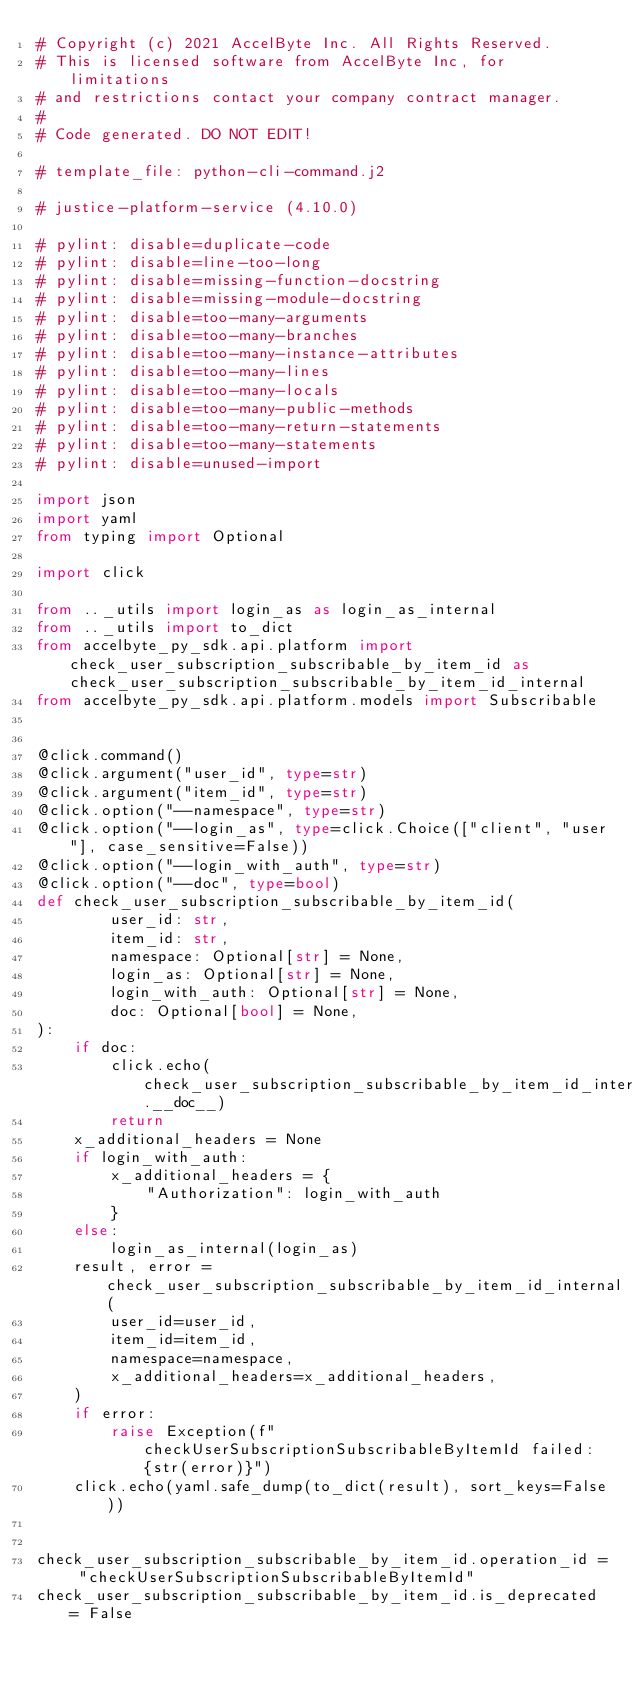Convert code to text. <code><loc_0><loc_0><loc_500><loc_500><_Python_># Copyright (c) 2021 AccelByte Inc. All Rights Reserved.
# This is licensed software from AccelByte Inc, for limitations
# and restrictions contact your company contract manager.
#
# Code generated. DO NOT EDIT!

# template_file: python-cli-command.j2

# justice-platform-service (4.10.0)

# pylint: disable=duplicate-code
# pylint: disable=line-too-long
# pylint: disable=missing-function-docstring
# pylint: disable=missing-module-docstring
# pylint: disable=too-many-arguments
# pylint: disable=too-many-branches
# pylint: disable=too-many-instance-attributes
# pylint: disable=too-many-lines
# pylint: disable=too-many-locals
# pylint: disable=too-many-public-methods
# pylint: disable=too-many-return-statements
# pylint: disable=too-many-statements
# pylint: disable=unused-import

import json
import yaml
from typing import Optional

import click

from .._utils import login_as as login_as_internal
from .._utils import to_dict
from accelbyte_py_sdk.api.platform import check_user_subscription_subscribable_by_item_id as check_user_subscription_subscribable_by_item_id_internal
from accelbyte_py_sdk.api.platform.models import Subscribable


@click.command()
@click.argument("user_id", type=str)
@click.argument("item_id", type=str)
@click.option("--namespace", type=str)
@click.option("--login_as", type=click.Choice(["client", "user"], case_sensitive=False))
@click.option("--login_with_auth", type=str)
@click.option("--doc", type=bool)
def check_user_subscription_subscribable_by_item_id(
        user_id: str,
        item_id: str,
        namespace: Optional[str] = None,
        login_as: Optional[str] = None,
        login_with_auth: Optional[str] = None,
        doc: Optional[bool] = None,
):
    if doc:
        click.echo(check_user_subscription_subscribable_by_item_id_internal.__doc__)
        return
    x_additional_headers = None
    if login_with_auth:
        x_additional_headers = {
            "Authorization": login_with_auth
        }
    else:
        login_as_internal(login_as)
    result, error = check_user_subscription_subscribable_by_item_id_internal(
        user_id=user_id,
        item_id=item_id,
        namespace=namespace,
        x_additional_headers=x_additional_headers,
    )
    if error:
        raise Exception(f"checkUserSubscriptionSubscribableByItemId failed: {str(error)}")
    click.echo(yaml.safe_dump(to_dict(result), sort_keys=False))


check_user_subscription_subscribable_by_item_id.operation_id = "checkUserSubscriptionSubscribableByItemId"
check_user_subscription_subscribable_by_item_id.is_deprecated = False
</code> 